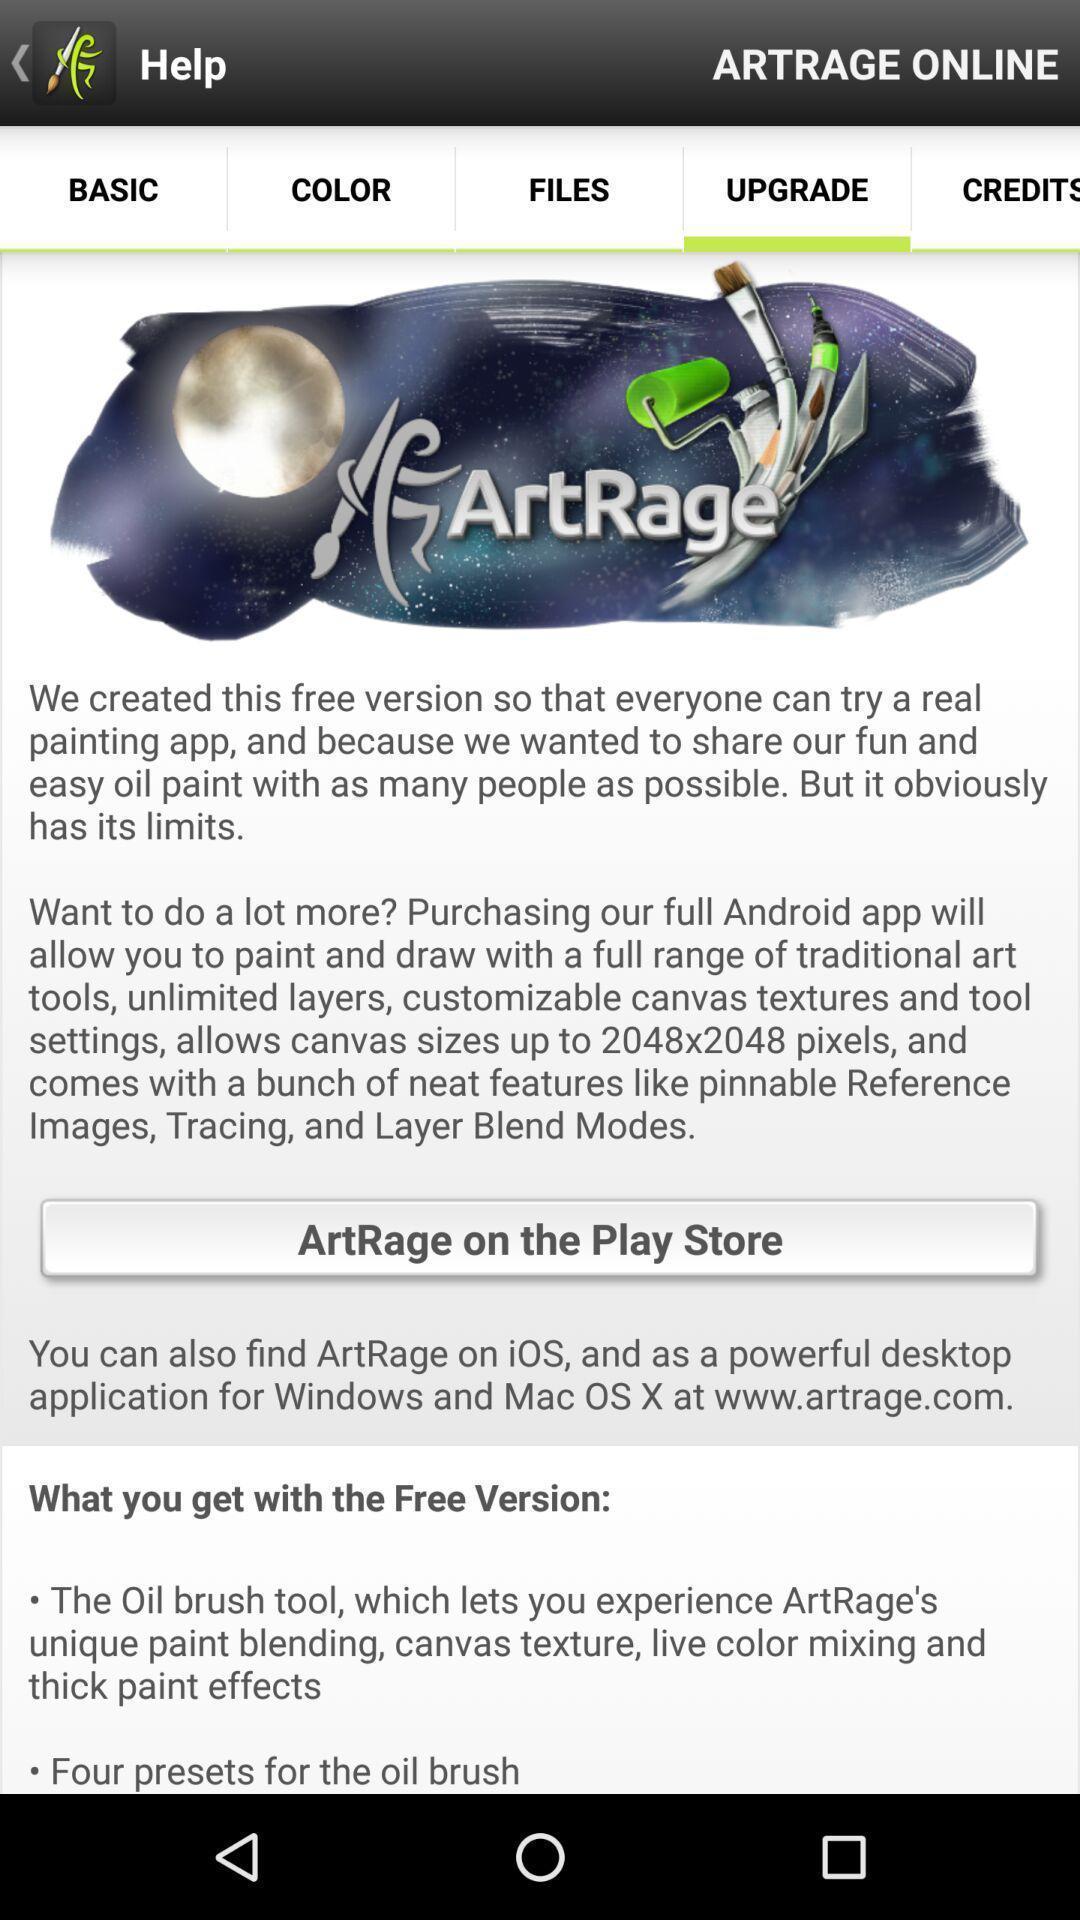What can you discern from this picture? Screen displaying the upgrade page of a painting app. 